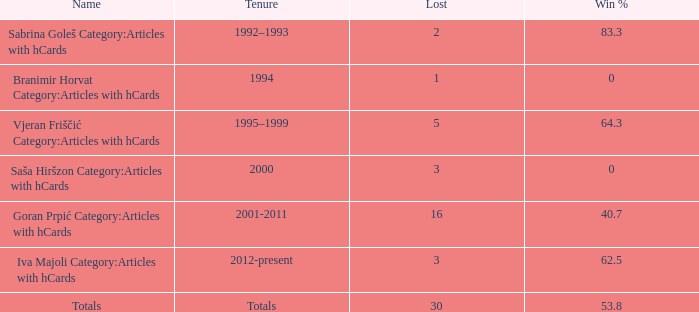Between 2001 and 2011, what is the total number of ties that have a win percentage above 0 and have lost more than 16 times? 0.0. 